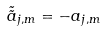Convert formula to latex. <formula><loc_0><loc_0><loc_500><loc_500>\tilde { \tilde { a } } _ { j , m } = - a _ { j , m }</formula> 